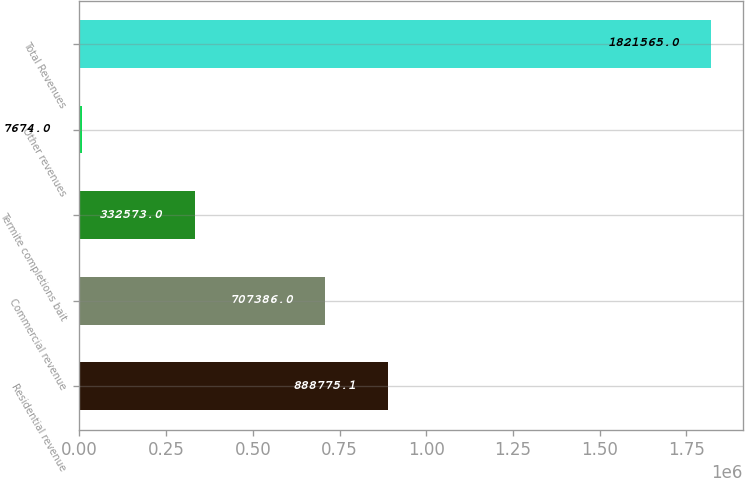Convert chart to OTSL. <chart><loc_0><loc_0><loc_500><loc_500><bar_chart><fcel>Residential revenue<fcel>Commercial revenue<fcel>Termite completions bait<fcel>Other revenues<fcel>Total Revenues<nl><fcel>888775<fcel>707386<fcel>332573<fcel>7674<fcel>1.82156e+06<nl></chart> 